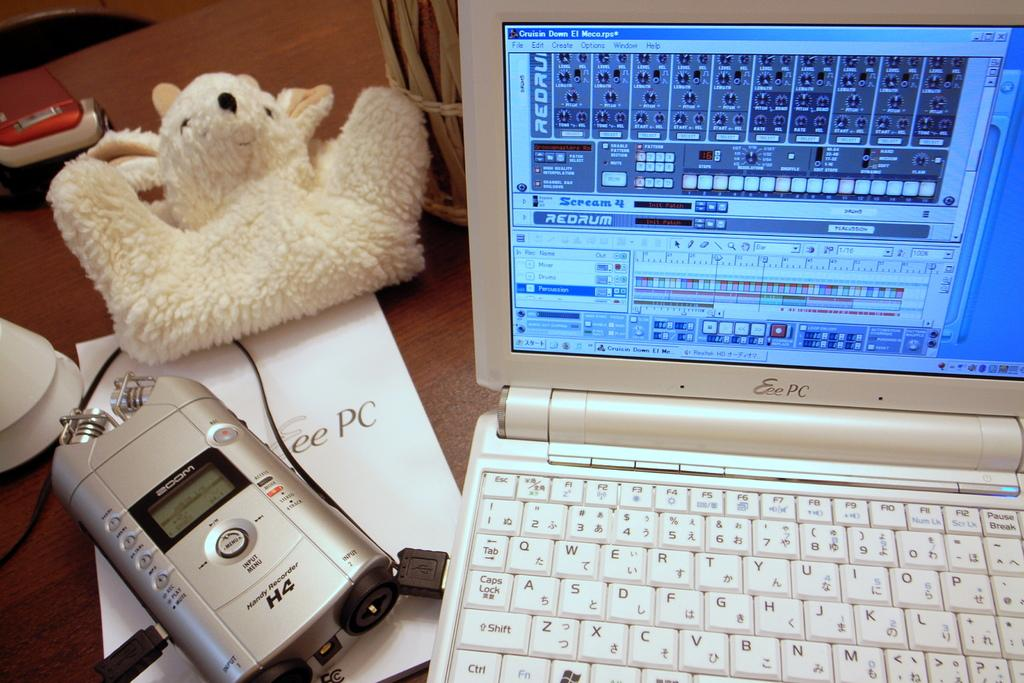Provide a one-sentence caption for the provided image. A laptop computer with Scream 4 Redrum on the screen. 